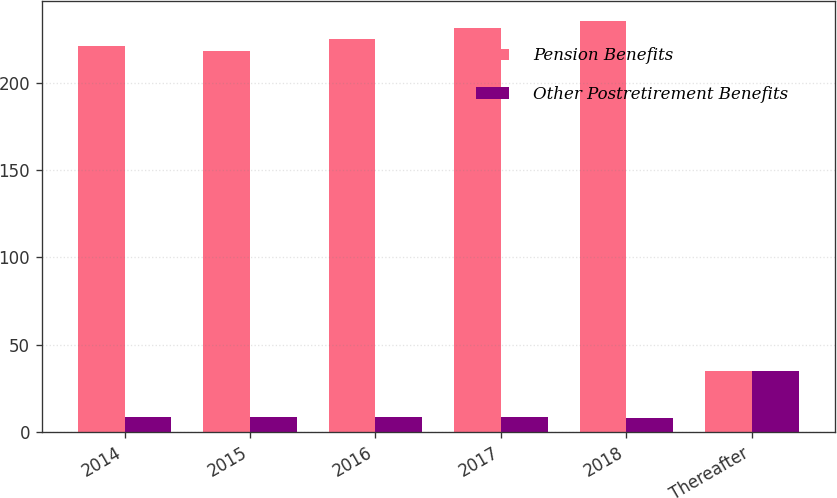Convert chart to OTSL. <chart><loc_0><loc_0><loc_500><loc_500><stacked_bar_chart><ecel><fcel>2014<fcel>2015<fcel>2016<fcel>2017<fcel>2018<fcel>Thereafter<nl><fcel>Pension Benefits<fcel>221<fcel>218<fcel>225<fcel>231<fcel>235<fcel>35<nl><fcel>Other Postretirement Benefits<fcel>9<fcel>9<fcel>9<fcel>9<fcel>8<fcel>35<nl></chart> 